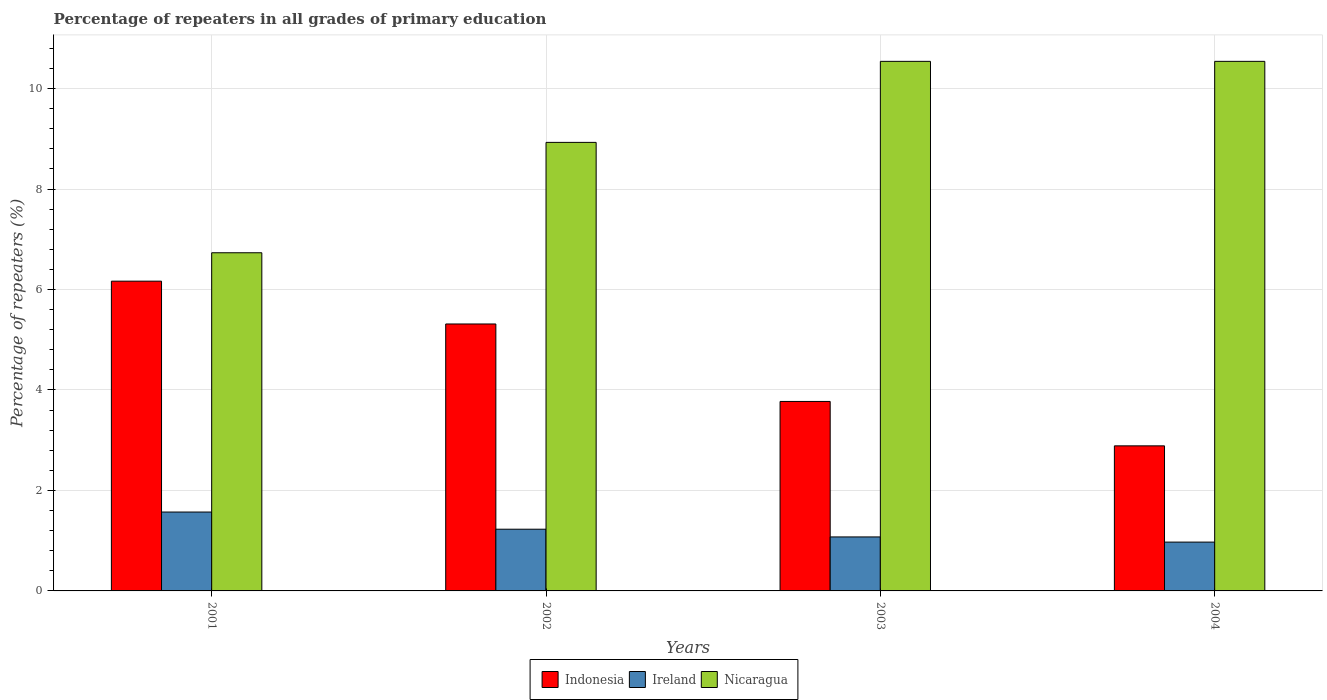Are the number of bars per tick equal to the number of legend labels?
Ensure brevity in your answer.  Yes. How many bars are there on the 2nd tick from the right?
Ensure brevity in your answer.  3. What is the label of the 3rd group of bars from the left?
Your response must be concise. 2003. What is the percentage of repeaters in Nicaragua in 2004?
Keep it short and to the point. 10.54. Across all years, what is the maximum percentage of repeaters in Ireland?
Offer a very short reply. 1.57. Across all years, what is the minimum percentage of repeaters in Indonesia?
Provide a short and direct response. 2.89. What is the total percentage of repeaters in Ireland in the graph?
Your response must be concise. 4.85. What is the difference between the percentage of repeaters in Ireland in 2001 and that in 2003?
Give a very brief answer. 0.5. What is the difference between the percentage of repeaters in Ireland in 2003 and the percentage of repeaters in Indonesia in 2002?
Your answer should be compact. -4.24. What is the average percentage of repeaters in Ireland per year?
Your answer should be very brief. 1.21. In the year 2001, what is the difference between the percentage of repeaters in Nicaragua and percentage of repeaters in Ireland?
Ensure brevity in your answer.  5.16. In how many years, is the percentage of repeaters in Ireland greater than 10.4 %?
Provide a short and direct response. 0. What is the ratio of the percentage of repeaters in Nicaragua in 2002 to that in 2003?
Ensure brevity in your answer.  0.85. What is the difference between the highest and the lowest percentage of repeaters in Indonesia?
Give a very brief answer. 3.28. In how many years, is the percentage of repeaters in Ireland greater than the average percentage of repeaters in Ireland taken over all years?
Give a very brief answer. 2. What does the 3rd bar from the left in 2003 represents?
Make the answer very short. Nicaragua. What does the 1st bar from the right in 2002 represents?
Keep it short and to the point. Nicaragua. Is it the case that in every year, the sum of the percentage of repeaters in Ireland and percentage of repeaters in Indonesia is greater than the percentage of repeaters in Nicaragua?
Give a very brief answer. No. How many bars are there?
Offer a very short reply. 12. How many years are there in the graph?
Provide a succinct answer. 4. Does the graph contain any zero values?
Offer a very short reply. No. How are the legend labels stacked?
Give a very brief answer. Horizontal. What is the title of the graph?
Offer a very short reply. Percentage of repeaters in all grades of primary education. Does "Namibia" appear as one of the legend labels in the graph?
Provide a succinct answer. No. What is the label or title of the Y-axis?
Your answer should be very brief. Percentage of repeaters (%). What is the Percentage of repeaters (%) in Indonesia in 2001?
Make the answer very short. 6.17. What is the Percentage of repeaters (%) of Ireland in 2001?
Provide a succinct answer. 1.57. What is the Percentage of repeaters (%) in Nicaragua in 2001?
Offer a terse response. 6.73. What is the Percentage of repeaters (%) in Indonesia in 2002?
Your response must be concise. 5.31. What is the Percentage of repeaters (%) in Ireland in 2002?
Your answer should be compact. 1.23. What is the Percentage of repeaters (%) of Nicaragua in 2002?
Give a very brief answer. 8.93. What is the Percentage of repeaters (%) of Indonesia in 2003?
Your response must be concise. 3.77. What is the Percentage of repeaters (%) in Ireland in 2003?
Make the answer very short. 1.07. What is the Percentage of repeaters (%) in Nicaragua in 2003?
Ensure brevity in your answer.  10.54. What is the Percentage of repeaters (%) in Indonesia in 2004?
Keep it short and to the point. 2.89. What is the Percentage of repeaters (%) of Ireland in 2004?
Your answer should be very brief. 0.97. What is the Percentage of repeaters (%) in Nicaragua in 2004?
Keep it short and to the point. 10.54. Across all years, what is the maximum Percentage of repeaters (%) in Indonesia?
Your answer should be very brief. 6.17. Across all years, what is the maximum Percentage of repeaters (%) in Ireland?
Provide a short and direct response. 1.57. Across all years, what is the maximum Percentage of repeaters (%) in Nicaragua?
Your response must be concise. 10.54. Across all years, what is the minimum Percentage of repeaters (%) in Indonesia?
Provide a short and direct response. 2.89. Across all years, what is the minimum Percentage of repeaters (%) in Ireland?
Your answer should be compact. 0.97. Across all years, what is the minimum Percentage of repeaters (%) of Nicaragua?
Make the answer very short. 6.73. What is the total Percentage of repeaters (%) in Indonesia in the graph?
Offer a very short reply. 18.14. What is the total Percentage of repeaters (%) of Ireland in the graph?
Your answer should be compact. 4.85. What is the total Percentage of repeaters (%) of Nicaragua in the graph?
Offer a terse response. 36.75. What is the difference between the Percentage of repeaters (%) in Indonesia in 2001 and that in 2002?
Provide a short and direct response. 0.85. What is the difference between the Percentage of repeaters (%) of Ireland in 2001 and that in 2002?
Provide a short and direct response. 0.34. What is the difference between the Percentage of repeaters (%) in Nicaragua in 2001 and that in 2002?
Provide a short and direct response. -2.2. What is the difference between the Percentage of repeaters (%) in Indonesia in 2001 and that in 2003?
Keep it short and to the point. 2.39. What is the difference between the Percentage of repeaters (%) of Ireland in 2001 and that in 2003?
Keep it short and to the point. 0.5. What is the difference between the Percentage of repeaters (%) of Nicaragua in 2001 and that in 2003?
Offer a very short reply. -3.81. What is the difference between the Percentage of repeaters (%) of Indonesia in 2001 and that in 2004?
Offer a terse response. 3.28. What is the difference between the Percentage of repeaters (%) in Ireland in 2001 and that in 2004?
Your response must be concise. 0.6. What is the difference between the Percentage of repeaters (%) in Nicaragua in 2001 and that in 2004?
Provide a short and direct response. -3.81. What is the difference between the Percentage of repeaters (%) in Indonesia in 2002 and that in 2003?
Make the answer very short. 1.54. What is the difference between the Percentage of repeaters (%) of Ireland in 2002 and that in 2003?
Make the answer very short. 0.15. What is the difference between the Percentage of repeaters (%) of Nicaragua in 2002 and that in 2003?
Your answer should be very brief. -1.61. What is the difference between the Percentage of repeaters (%) in Indonesia in 2002 and that in 2004?
Ensure brevity in your answer.  2.43. What is the difference between the Percentage of repeaters (%) in Ireland in 2002 and that in 2004?
Keep it short and to the point. 0.26. What is the difference between the Percentage of repeaters (%) of Nicaragua in 2002 and that in 2004?
Your answer should be compact. -1.61. What is the difference between the Percentage of repeaters (%) in Indonesia in 2003 and that in 2004?
Offer a terse response. 0.88. What is the difference between the Percentage of repeaters (%) of Ireland in 2003 and that in 2004?
Provide a succinct answer. 0.1. What is the difference between the Percentage of repeaters (%) of Indonesia in 2001 and the Percentage of repeaters (%) of Ireland in 2002?
Give a very brief answer. 4.94. What is the difference between the Percentage of repeaters (%) in Indonesia in 2001 and the Percentage of repeaters (%) in Nicaragua in 2002?
Keep it short and to the point. -2.76. What is the difference between the Percentage of repeaters (%) of Ireland in 2001 and the Percentage of repeaters (%) of Nicaragua in 2002?
Your answer should be very brief. -7.36. What is the difference between the Percentage of repeaters (%) of Indonesia in 2001 and the Percentage of repeaters (%) of Ireland in 2003?
Your response must be concise. 5.09. What is the difference between the Percentage of repeaters (%) of Indonesia in 2001 and the Percentage of repeaters (%) of Nicaragua in 2003?
Provide a short and direct response. -4.38. What is the difference between the Percentage of repeaters (%) in Ireland in 2001 and the Percentage of repeaters (%) in Nicaragua in 2003?
Give a very brief answer. -8.97. What is the difference between the Percentage of repeaters (%) in Indonesia in 2001 and the Percentage of repeaters (%) in Ireland in 2004?
Your answer should be compact. 5.19. What is the difference between the Percentage of repeaters (%) in Indonesia in 2001 and the Percentage of repeaters (%) in Nicaragua in 2004?
Offer a terse response. -4.38. What is the difference between the Percentage of repeaters (%) in Ireland in 2001 and the Percentage of repeaters (%) in Nicaragua in 2004?
Give a very brief answer. -8.97. What is the difference between the Percentage of repeaters (%) of Indonesia in 2002 and the Percentage of repeaters (%) of Ireland in 2003?
Provide a succinct answer. 4.24. What is the difference between the Percentage of repeaters (%) in Indonesia in 2002 and the Percentage of repeaters (%) in Nicaragua in 2003?
Give a very brief answer. -5.23. What is the difference between the Percentage of repeaters (%) of Ireland in 2002 and the Percentage of repeaters (%) of Nicaragua in 2003?
Provide a succinct answer. -9.31. What is the difference between the Percentage of repeaters (%) in Indonesia in 2002 and the Percentage of repeaters (%) in Ireland in 2004?
Your answer should be very brief. 4.34. What is the difference between the Percentage of repeaters (%) of Indonesia in 2002 and the Percentage of repeaters (%) of Nicaragua in 2004?
Offer a very short reply. -5.23. What is the difference between the Percentage of repeaters (%) of Ireland in 2002 and the Percentage of repeaters (%) of Nicaragua in 2004?
Ensure brevity in your answer.  -9.31. What is the difference between the Percentage of repeaters (%) of Indonesia in 2003 and the Percentage of repeaters (%) of Ireland in 2004?
Your answer should be very brief. 2.8. What is the difference between the Percentage of repeaters (%) of Indonesia in 2003 and the Percentage of repeaters (%) of Nicaragua in 2004?
Your answer should be compact. -6.77. What is the difference between the Percentage of repeaters (%) of Ireland in 2003 and the Percentage of repeaters (%) of Nicaragua in 2004?
Make the answer very short. -9.47. What is the average Percentage of repeaters (%) of Indonesia per year?
Your answer should be very brief. 4.54. What is the average Percentage of repeaters (%) of Ireland per year?
Provide a succinct answer. 1.21. What is the average Percentage of repeaters (%) in Nicaragua per year?
Your answer should be very brief. 9.19. In the year 2001, what is the difference between the Percentage of repeaters (%) of Indonesia and Percentage of repeaters (%) of Ireland?
Ensure brevity in your answer.  4.6. In the year 2001, what is the difference between the Percentage of repeaters (%) of Indonesia and Percentage of repeaters (%) of Nicaragua?
Give a very brief answer. -0.57. In the year 2001, what is the difference between the Percentage of repeaters (%) of Ireland and Percentage of repeaters (%) of Nicaragua?
Your response must be concise. -5.16. In the year 2002, what is the difference between the Percentage of repeaters (%) of Indonesia and Percentage of repeaters (%) of Ireland?
Provide a succinct answer. 4.09. In the year 2002, what is the difference between the Percentage of repeaters (%) of Indonesia and Percentage of repeaters (%) of Nicaragua?
Your answer should be very brief. -3.62. In the year 2002, what is the difference between the Percentage of repeaters (%) in Ireland and Percentage of repeaters (%) in Nicaragua?
Your response must be concise. -7.7. In the year 2003, what is the difference between the Percentage of repeaters (%) of Indonesia and Percentage of repeaters (%) of Ireland?
Offer a terse response. 2.7. In the year 2003, what is the difference between the Percentage of repeaters (%) in Indonesia and Percentage of repeaters (%) in Nicaragua?
Your answer should be compact. -6.77. In the year 2003, what is the difference between the Percentage of repeaters (%) in Ireland and Percentage of repeaters (%) in Nicaragua?
Provide a succinct answer. -9.47. In the year 2004, what is the difference between the Percentage of repeaters (%) of Indonesia and Percentage of repeaters (%) of Ireland?
Keep it short and to the point. 1.92. In the year 2004, what is the difference between the Percentage of repeaters (%) in Indonesia and Percentage of repeaters (%) in Nicaragua?
Ensure brevity in your answer.  -7.65. In the year 2004, what is the difference between the Percentage of repeaters (%) of Ireland and Percentage of repeaters (%) of Nicaragua?
Provide a short and direct response. -9.57. What is the ratio of the Percentage of repeaters (%) in Indonesia in 2001 to that in 2002?
Give a very brief answer. 1.16. What is the ratio of the Percentage of repeaters (%) in Ireland in 2001 to that in 2002?
Give a very brief answer. 1.28. What is the ratio of the Percentage of repeaters (%) of Nicaragua in 2001 to that in 2002?
Make the answer very short. 0.75. What is the ratio of the Percentage of repeaters (%) of Indonesia in 2001 to that in 2003?
Keep it short and to the point. 1.63. What is the ratio of the Percentage of repeaters (%) of Ireland in 2001 to that in 2003?
Provide a short and direct response. 1.46. What is the ratio of the Percentage of repeaters (%) in Nicaragua in 2001 to that in 2003?
Your response must be concise. 0.64. What is the ratio of the Percentage of repeaters (%) in Indonesia in 2001 to that in 2004?
Your answer should be very brief. 2.14. What is the ratio of the Percentage of repeaters (%) in Ireland in 2001 to that in 2004?
Give a very brief answer. 1.62. What is the ratio of the Percentage of repeaters (%) of Nicaragua in 2001 to that in 2004?
Offer a terse response. 0.64. What is the ratio of the Percentage of repeaters (%) of Indonesia in 2002 to that in 2003?
Ensure brevity in your answer.  1.41. What is the ratio of the Percentage of repeaters (%) of Ireland in 2002 to that in 2003?
Offer a terse response. 1.14. What is the ratio of the Percentage of repeaters (%) in Nicaragua in 2002 to that in 2003?
Provide a succinct answer. 0.85. What is the ratio of the Percentage of repeaters (%) of Indonesia in 2002 to that in 2004?
Make the answer very short. 1.84. What is the ratio of the Percentage of repeaters (%) in Ireland in 2002 to that in 2004?
Your answer should be compact. 1.26. What is the ratio of the Percentage of repeaters (%) in Nicaragua in 2002 to that in 2004?
Provide a succinct answer. 0.85. What is the ratio of the Percentage of repeaters (%) in Indonesia in 2003 to that in 2004?
Your answer should be very brief. 1.31. What is the ratio of the Percentage of repeaters (%) of Ireland in 2003 to that in 2004?
Your response must be concise. 1.11. What is the ratio of the Percentage of repeaters (%) of Nicaragua in 2003 to that in 2004?
Provide a succinct answer. 1. What is the difference between the highest and the second highest Percentage of repeaters (%) in Indonesia?
Ensure brevity in your answer.  0.85. What is the difference between the highest and the second highest Percentage of repeaters (%) of Ireland?
Offer a terse response. 0.34. What is the difference between the highest and the lowest Percentage of repeaters (%) of Indonesia?
Provide a short and direct response. 3.28. What is the difference between the highest and the lowest Percentage of repeaters (%) of Ireland?
Ensure brevity in your answer.  0.6. What is the difference between the highest and the lowest Percentage of repeaters (%) of Nicaragua?
Give a very brief answer. 3.81. 